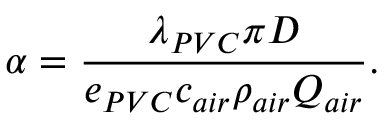<formula> <loc_0><loc_0><loc_500><loc_500>\alpha = \frac { \lambda _ { P V C } \pi D } { e _ { P V C } c _ { a i r } \rho _ { a i r } Q _ { a i r } } .</formula> 